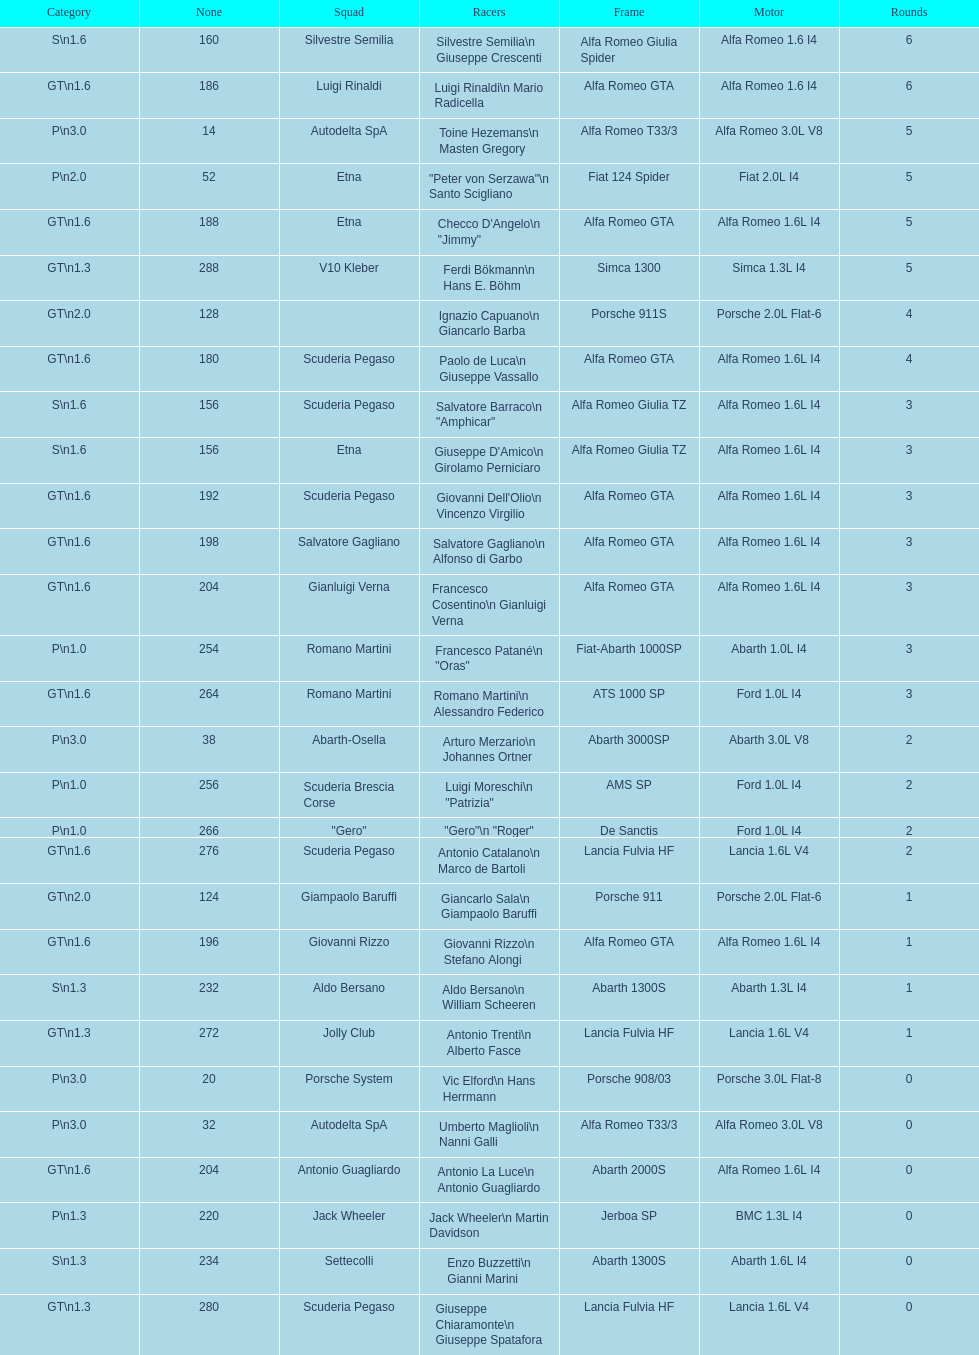Which chassis is in the middle of simca 1300 and alfa romeo gta? Porsche 911S. 